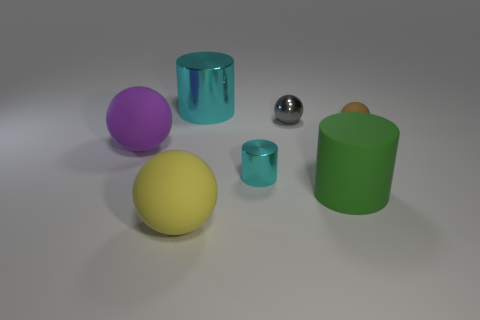What material is the big object that is both in front of the purple rubber thing and left of the big green matte cylinder?
Make the answer very short. Rubber. Is the shape of the brown thing the same as the tiny thing that is behind the small brown ball?
Provide a succinct answer. Yes. What material is the big object that is to the right of the cyan cylinder in front of the metal thing that is behind the gray metallic thing?
Offer a terse response. Rubber. How many other things are the same size as the green rubber cylinder?
Offer a very short reply. 3. Do the small metal sphere and the big metallic thing have the same color?
Your answer should be compact. No. There is a large matte thing right of the cylinder behind the tiny cyan metal object; what number of tiny metal objects are in front of it?
Provide a succinct answer. 0. There is a cyan thing to the left of the cyan metal cylinder that is in front of the large shiny cylinder; what is it made of?
Ensure brevity in your answer.  Metal. Are there any small cyan metallic things that have the same shape as the large cyan thing?
Your answer should be very brief. Yes. There is a shiny cylinder that is the same size as the purple rubber sphere; what color is it?
Provide a short and direct response. Cyan. What number of things are matte objects that are to the left of the brown matte sphere or matte things behind the large yellow matte thing?
Provide a short and direct response. 4. 